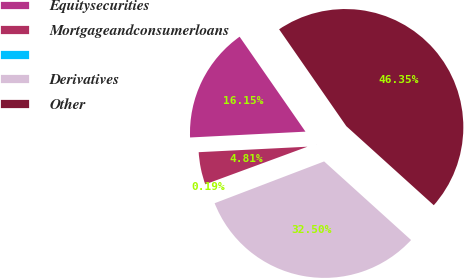Convert chart. <chart><loc_0><loc_0><loc_500><loc_500><pie_chart><fcel>Equitysecurities<fcel>Mortgageandconsumerloans<fcel>Unnamed: 2<fcel>Derivatives<fcel>Other<nl><fcel>16.15%<fcel>4.81%<fcel>0.19%<fcel>32.5%<fcel>46.35%<nl></chart> 